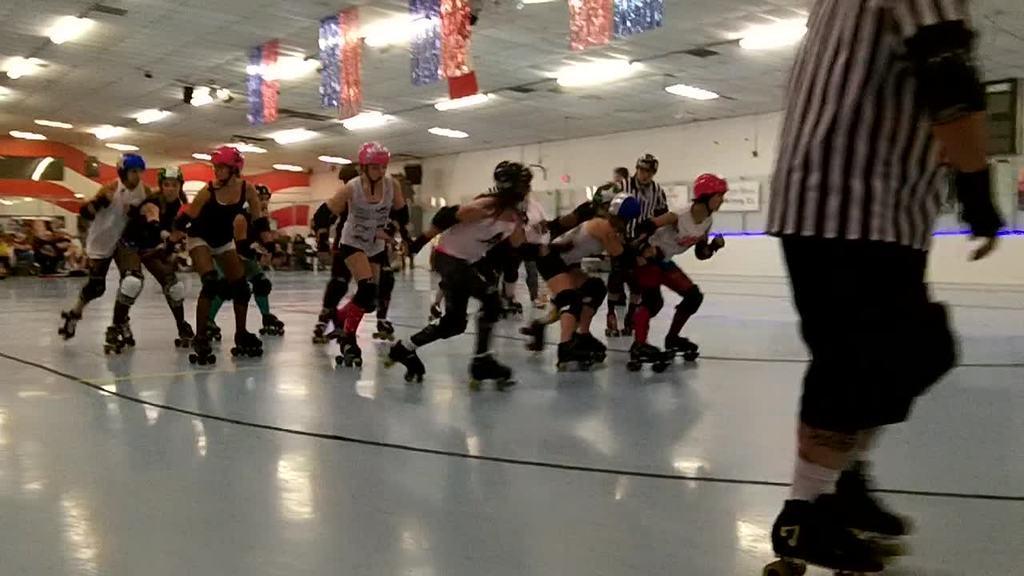Could you give a brief overview of what you see in this image? In this picture we can observe some people skating on the skating rink. All of them are wearing helmets on their heads. We can observe some ribbons hanged to the ceiling. There are some lights. In the background there is a wall which is in white color. 